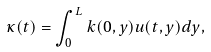Convert formula to latex. <formula><loc_0><loc_0><loc_500><loc_500>\kappa ( t ) = \int _ { 0 } ^ { L } k ( 0 , y ) u ( t , y ) d y ,</formula> 